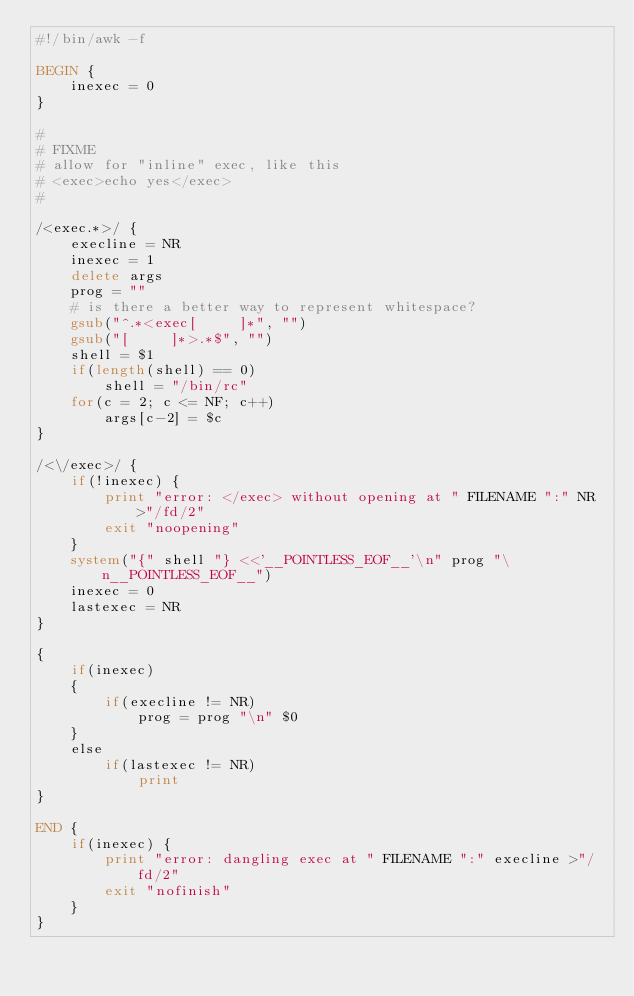Convert code to text. <code><loc_0><loc_0><loc_500><loc_500><_Awk_>#!/bin/awk -f

BEGIN {
	inexec = 0
}

#
# FIXME
# allow for "inline" exec, like this
# <exec>echo yes</exec>
#

/<exec.*>/ {
	execline = NR
	inexec = 1
	delete args
	prog = ""
	# is there a better way to represent whitespace?
	gsub("^.*<exec[ 	]*", "")
	gsub("[ 	]*>.*$", "")
	shell = $1
	if(length(shell) == 0)
		shell = "/bin/rc"
	for(c = 2; c <= NF; c++)
 		args[c-2] = $c
}

/<\/exec>/ {
	if(!inexec) {
		print "error: </exec> without opening at " FILENAME ":" NR >"/fd/2"
		exit "noopening"
	}
	system("{" shell "} <<'__POINTLESS_EOF__'\n" prog "\n__POINTLESS_EOF__")
	inexec = 0
	lastexec = NR
}

{
	if(inexec)
	{
		if(execline != NR)
			prog = prog "\n" $0
	}
	else
		if(lastexec != NR)
			print
}

END {
	if(inexec) {
		print "error: dangling exec at " FILENAME ":" execline >"/fd/2"
		exit "nofinish"
	}
}
</code> 